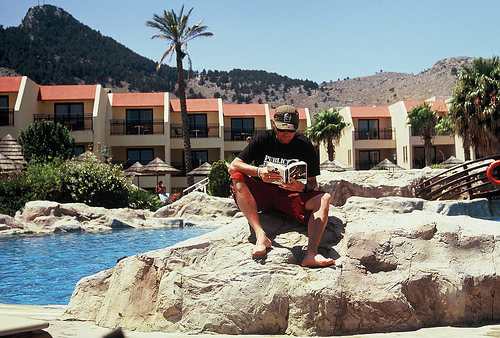<image>
Is there a water under the rock? No. The water is not positioned under the rock. The vertical relationship between these objects is different. Is the man in front of the tree? Yes. The man is positioned in front of the tree, appearing closer to the camera viewpoint. 